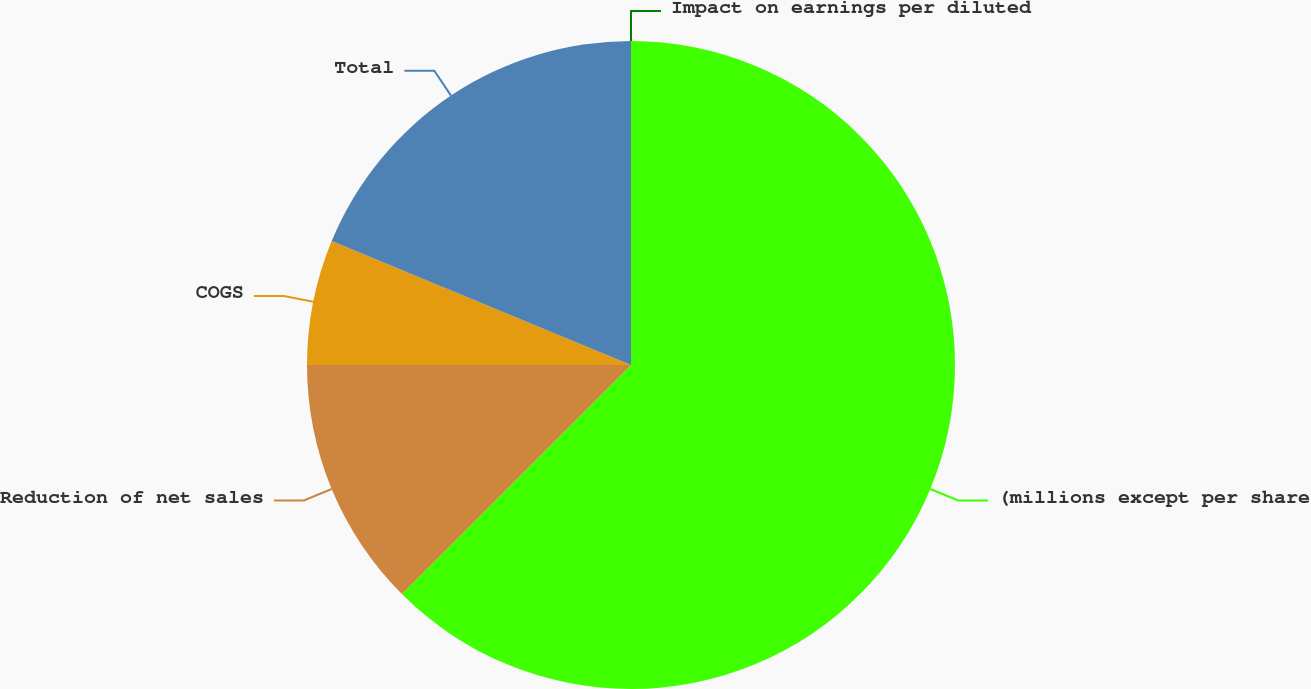Convert chart. <chart><loc_0><loc_0><loc_500><loc_500><pie_chart><fcel>(millions except per share<fcel>Reduction of net sales<fcel>COGS<fcel>Total<fcel>Impact on earnings per diluted<nl><fcel>62.5%<fcel>12.5%<fcel>6.25%<fcel>18.75%<fcel>0.0%<nl></chart> 